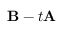<formula> <loc_0><loc_0><loc_500><loc_500>{ B } - t { A }</formula> 